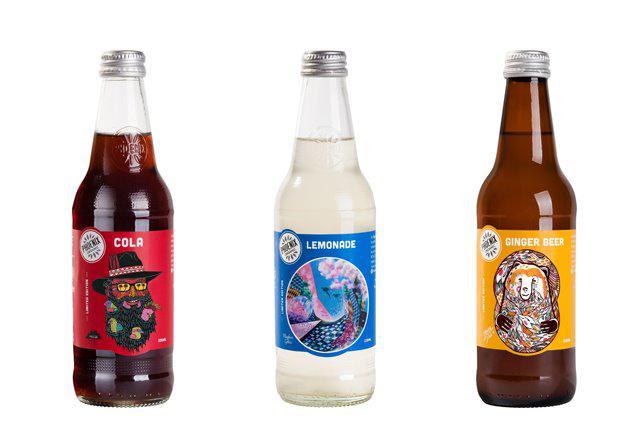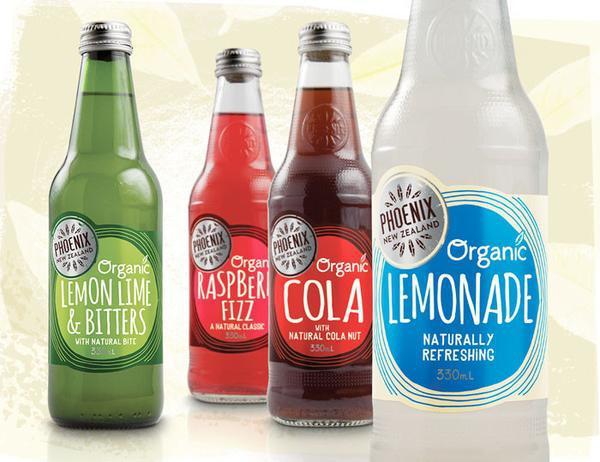The first image is the image on the left, the second image is the image on the right. For the images displayed, is the sentence "One image contains exactly four bottles with various colored circle shapes on each label, and the other image contains no more than four bottles with colorful imagery on their labels." factually correct? Answer yes or no. Yes. The first image is the image on the left, the second image is the image on the right. Examine the images to the left and right. Is the description "There are more bottles in the image on the left." accurate? Answer yes or no. No. 